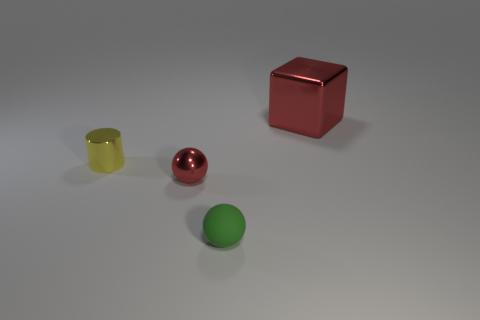What is the shape of the tiny red thing?
Provide a succinct answer. Sphere. Are the yellow cylinder and the green ball made of the same material?
Your response must be concise. No. Are there the same number of matte things that are behind the green thing and tiny red things that are in front of the small yellow cylinder?
Your answer should be very brief. No. There is a small thing that is left of the red metallic object that is in front of the big shiny block; is there a red thing that is to the left of it?
Provide a short and direct response. No. Does the rubber object have the same size as the metal cylinder?
Ensure brevity in your answer.  Yes. There is a tiny thing that is in front of the red object that is in front of the thing that is right of the tiny rubber ball; what color is it?
Offer a terse response. Green. How many objects are the same color as the big metallic block?
Keep it short and to the point. 1. How many large things are blocks or cyan metal cylinders?
Offer a very short reply. 1. Is there another red thing of the same shape as the tiny matte object?
Provide a short and direct response. Yes. Is the shape of the tiny green matte object the same as the big object?
Offer a terse response. No. 